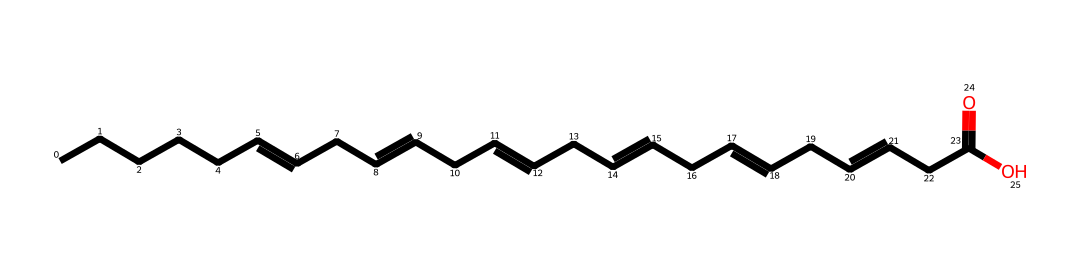How many carbon atoms are in docosahexaenoic acid? The SMILES representation indicates a long chain of carbon atoms, and by counting all the 'C's in the linear structure, we find there are 22 carbon atoms.
Answer: 22 What functional group is present in docosahexaenoic acid? The presence of 'C(=O)O' in the SMILES indicates a carboxylic acid functional group, which is characterized by the carbon double-bonded to oxygen and also bonded to a hydroxyl group (-OH).
Answer: carboxylic acid How many double bonds are in docosahexaenoic acid? The SMILES shows 'CC=CC=CC=CC=CC=' which indicates there are multiple segments with double bonds. Upon careful inspection, we find there are 6 double bonds in the chain.
Answer: 6 What is the total number of hydrogen atoms in docosahexaenoic acid? Given that the formula for saturation for fatty acids is CnH(2n+1)COOH, where n is the number of carbon atoms, for 22 carbon atoms, the total hydrogen atoms can be calculated: (2*22 + 1) - (2*6) + 1 = 32.
Answer: 32 Is docosahexaenoic acid saturated or unsaturated? The presence of multiple double bonds in the structure, as indicated by 'C=C', indicates that docosahexaenoic acid is an unsaturated fatty acid.
Answer: unsaturated 